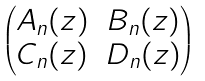Convert formula to latex. <formula><loc_0><loc_0><loc_500><loc_500>\begin{pmatrix} A _ { n } ( z ) & B _ { n } ( z ) \\ C _ { n } ( z ) & D _ { n } ( z ) \end{pmatrix}</formula> 